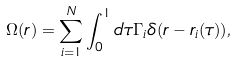Convert formula to latex. <formula><loc_0><loc_0><loc_500><loc_500>\Omega ( { r } ) = \sum _ { i = 1 } ^ { N } \int _ { 0 } ^ { 1 } d \tau \Gamma _ { i } \delta ( { r } - { r } _ { i } ( \tau ) ) ,</formula> 